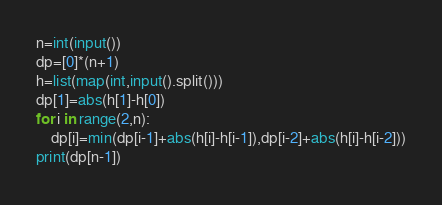<code> <loc_0><loc_0><loc_500><loc_500><_Python_>n=int(input())
dp=[0]*(n+1)
h=list(map(int,input().split()))
dp[1]=abs(h[1]-h[0])
for i in range(2,n):
    dp[i]=min(dp[i-1]+abs(h[i]-h[i-1]),dp[i-2]+abs(h[i]-h[i-2]))
print(dp[n-1])</code> 